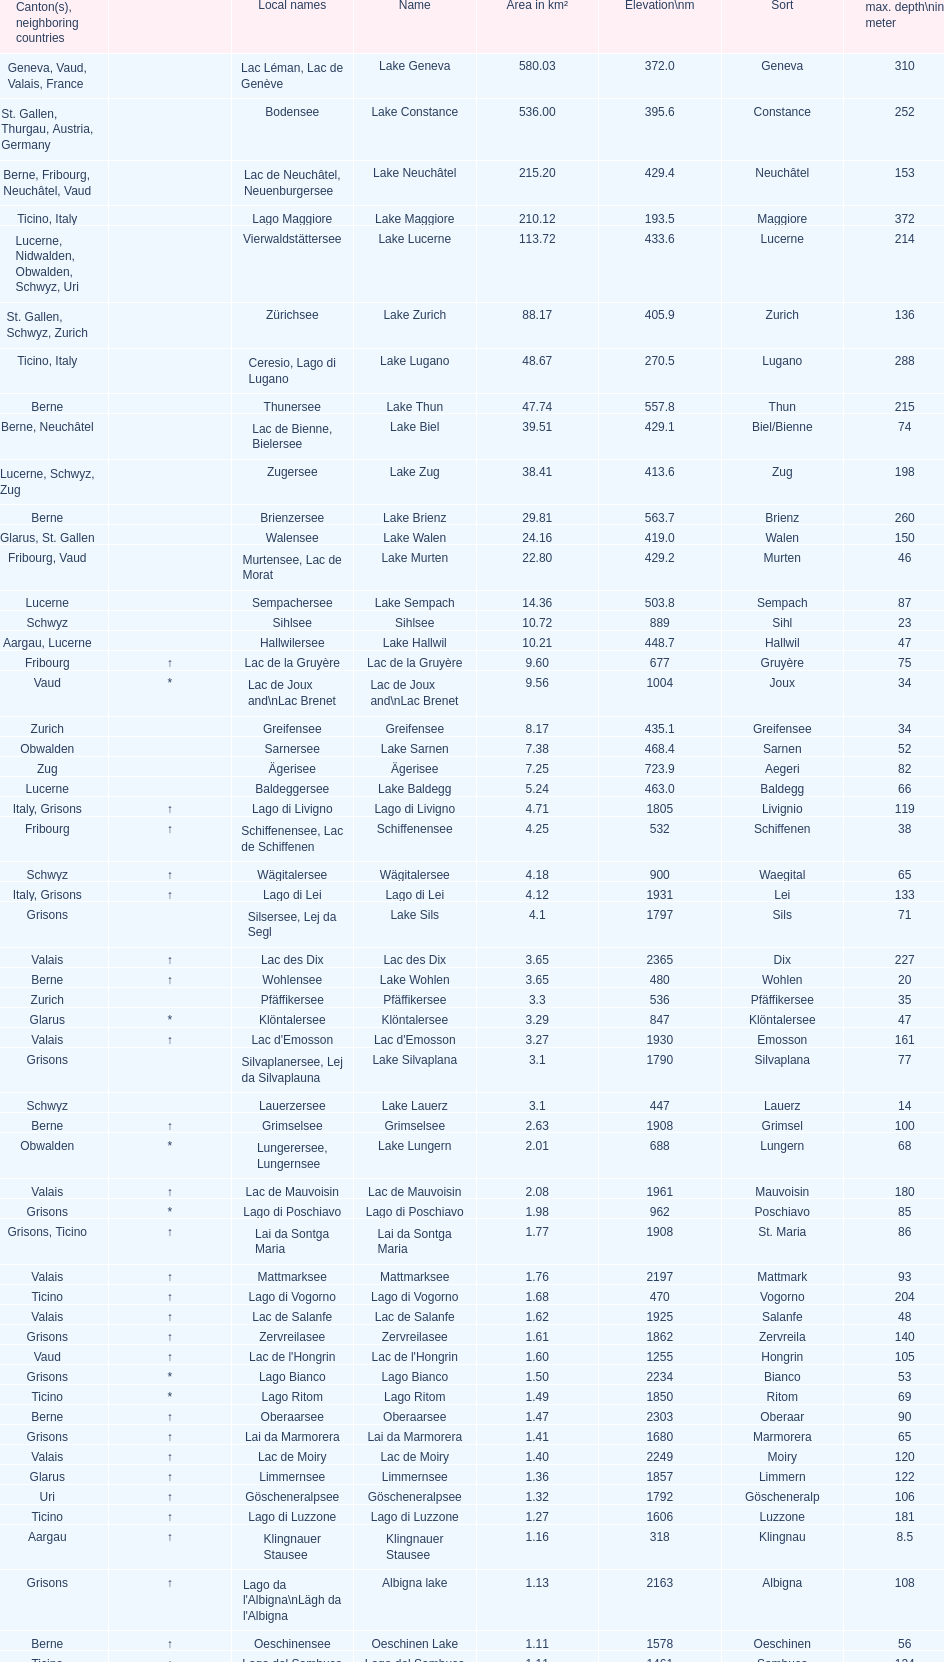I'm looking to parse the entire table for insights. Could you assist me with that? {'header': ['Canton(s), neighboring countries', '', 'Local names', 'Name', 'Area in km²', 'Elevation\\nm', 'Sort', 'max. depth\\nin meter'], 'rows': [['Geneva, Vaud, Valais, France', '', 'Lac Léman, Lac de Genève', 'Lake Geneva', '580.03', '372.0', 'Geneva', '310'], ['St. Gallen, Thurgau, Austria, Germany', '', 'Bodensee', 'Lake Constance', '536.00', '395.6', 'Constance', '252'], ['Berne, Fribourg, Neuchâtel, Vaud', '', 'Lac de Neuchâtel, Neuenburgersee', 'Lake Neuchâtel', '215.20', '429.4', 'Neuchâtel', '153'], ['Ticino, Italy', '', 'Lago Maggiore', 'Lake Maggiore', '210.12', '193.5', 'Maggiore', '372'], ['Lucerne, Nidwalden, Obwalden, Schwyz, Uri', '', 'Vierwaldstättersee', 'Lake Lucerne', '113.72', '433.6', 'Lucerne', '214'], ['St. Gallen, Schwyz, Zurich', '', 'Zürichsee', 'Lake Zurich', '88.17', '405.9', 'Zurich', '136'], ['Ticino, Italy', '', 'Ceresio, Lago di Lugano', 'Lake Lugano', '48.67', '270.5', 'Lugano', '288'], ['Berne', '', 'Thunersee', 'Lake Thun', '47.74', '557.8', 'Thun', '215'], ['Berne, Neuchâtel', '', 'Lac de Bienne, Bielersee', 'Lake Biel', '39.51', '429.1', 'Biel/Bienne', '74'], ['Lucerne, Schwyz, Zug', '', 'Zugersee', 'Lake Zug', '38.41', '413.6', 'Zug', '198'], ['Berne', '', 'Brienzersee', 'Lake Brienz', '29.81', '563.7', 'Brienz', '260'], ['Glarus, St. Gallen', '', 'Walensee', 'Lake Walen', '24.16', '419.0', 'Walen', '150'], ['Fribourg, Vaud', '', 'Murtensee, Lac de Morat', 'Lake Murten', '22.80', '429.2', 'Murten', '46'], ['Lucerne', '', 'Sempachersee', 'Lake Sempach', '14.36', '503.8', 'Sempach', '87'], ['Schwyz', '', 'Sihlsee', 'Sihlsee', '10.72', '889', 'Sihl', '23'], ['Aargau, Lucerne', '', 'Hallwilersee', 'Lake Hallwil', '10.21', '448.7', 'Hallwil', '47'], ['Fribourg', '↑', 'Lac de la Gruyère', 'Lac de la Gruyère', '9.60', '677', 'Gruyère', '75'], ['Vaud', '*', 'Lac de Joux and\\nLac Brenet', 'Lac de Joux and\\nLac Brenet', '9.56', '1004', 'Joux', '34'], ['Zurich', '', 'Greifensee', 'Greifensee', '8.17', '435.1', 'Greifensee', '34'], ['Obwalden', '', 'Sarnersee', 'Lake Sarnen', '7.38', '468.4', 'Sarnen', '52'], ['Zug', '', 'Ägerisee', 'Ägerisee', '7.25', '723.9', 'Aegeri', '82'], ['Lucerne', '', 'Baldeggersee', 'Lake Baldegg', '5.24', '463.0', 'Baldegg', '66'], ['Italy, Grisons', '↑', 'Lago di Livigno', 'Lago di Livigno', '4.71', '1805', 'Livignio', '119'], ['Fribourg', '↑', 'Schiffenensee, Lac de Schiffenen', 'Schiffenensee', '4.25', '532', 'Schiffenen', '38'], ['Schwyz', '↑', 'Wägitalersee', 'Wägitalersee', '4.18', '900', 'Waegital', '65'], ['Italy, Grisons', '↑', 'Lago di Lei', 'Lago di Lei', '4.12', '1931', 'Lei', '133'], ['Grisons', '', 'Silsersee, Lej da Segl', 'Lake Sils', '4.1', '1797', 'Sils', '71'], ['Valais', '↑', 'Lac des Dix', 'Lac des Dix', '3.65', '2365', 'Dix', '227'], ['Berne', '↑', 'Wohlensee', 'Lake Wohlen', '3.65', '480', 'Wohlen', '20'], ['Zurich', '', 'Pfäffikersee', 'Pfäffikersee', '3.3', '536', 'Pfäffikersee', '35'], ['Glarus', '*', 'Klöntalersee', 'Klöntalersee', '3.29', '847', 'Klöntalersee', '47'], ['Valais', '↑', "Lac d'Emosson", "Lac d'Emosson", '3.27', '1930', 'Emosson', '161'], ['Grisons', '', 'Silvaplanersee, Lej da Silvaplauna', 'Lake Silvaplana', '3.1', '1790', 'Silvaplana', '77'], ['Schwyz', '', 'Lauerzersee', 'Lake Lauerz', '3.1', '447', 'Lauerz', '14'], ['Berne', '↑', 'Grimselsee', 'Grimselsee', '2.63', '1908', 'Grimsel', '100'], ['Obwalden', '*', 'Lungerersee, Lungernsee', 'Lake Lungern', '2.01', '688', 'Lungern', '68'], ['Valais', '↑', 'Lac de Mauvoisin', 'Lac de Mauvoisin', '2.08', '1961', 'Mauvoisin', '180'], ['Grisons', '*', 'Lago di Poschiavo', 'Lago di Poschiavo', '1.98', '962', 'Poschiavo', '85'], ['Grisons, Ticino', '↑', 'Lai da Sontga Maria', 'Lai da Sontga Maria', '1.77', '1908', 'St. Maria', '86'], ['Valais', '↑', 'Mattmarksee', 'Mattmarksee', '1.76', '2197', 'Mattmark', '93'], ['Ticino', '↑', 'Lago di Vogorno', 'Lago di Vogorno', '1.68', '470', 'Vogorno', '204'], ['Valais', '↑', 'Lac de Salanfe', 'Lac de Salanfe', '1.62', '1925', 'Salanfe', '48'], ['Grisons', '↑', 'Zervreilasee', 'Zervreilasee', '1.61', '1862', 'Zervreila', '140'], ['Vaud', '↑', "Lac de l'Hongrin", "Lac de l'Hongrin", '1.60', '1255', 'Hongrin', '105'], ['Grisons', '*', 'Lago Bianco', 'Lago Bianco', '1.50', '2234', 'Bianco', '53'], ['Ticino', '*', 'Lago Ritom', 'Lago Ritom', '1.49', '1850', 'Ritom', '69'], ['Berne', '↑', 'Oberaarsee', 'Oberaarsee', '1.47', '2303', 'Oberaar', '90'], ['Grisons', '↑', 'Lai da Marmorera', 'Lai da Marmorera', '1.41', '1680', 'Marmorera', '65'], ['Valais', '↑', 'Lac de Moiry', 'Lac de Moiry', '1.40', '2249', 'Moiry', '120'], ['Glarus', '↑', 'Limmernsee', 'Limmernsee', '1.36', '1857', 'Limmern', '122'], ['Uri', '↑', 'Göscheneralpsee', 'Göscheneralpsee', '1.32', '1792', 'Göscheneralp', '106'], ['Ticino', '↑', 'Lago di Luzzone', 'Lago di Luzzone', '1.27', '1606', 'Luzzone', '181'], ['Aargau', '↑', 'Klingnauer Stausee', 'Klingnauer Stausee', '1.16', '318', 'Klingnau', '8.5'], ['Grisons', '↑', "Lago da l'Albigna\\nLägh da l'Albigna", 'Albigna lake', '1.13', '2163', 'Albigna', '108'], ['Berne', '↑', 'Oeschinensee', 'Oeschinen Lake', '1.11', '1578', 'Oeschinen', '56'], ['Ticino', '↑', 'Lago del Sambuco', 'Lago del Sambuco', '1.11', '1461', 'Sambuco', '124']]} What's the total max depth of lake geneva and lake constance combined? 562. 